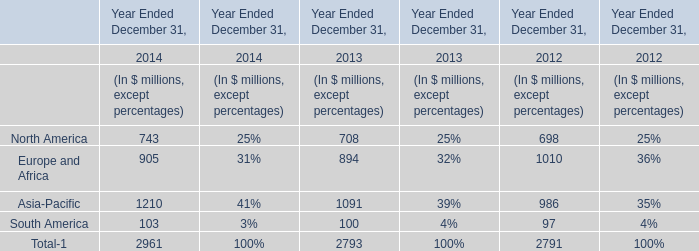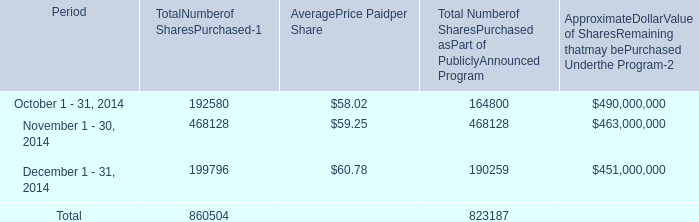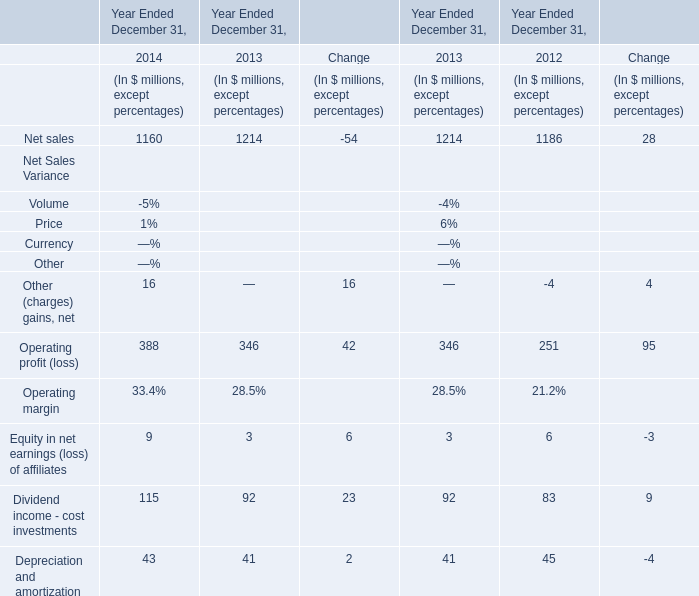what is the total value paid for purchased shares during november 2014? 
Computations: ((468128 * 59.25) / 1000000)
Answer: 27.73658. 